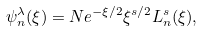<formula> <loc_0><loc_0><loc_500><loc_500>\psi _ { n } ^ { \lambda } ( \xi ) = N e ^ { - \xi / 2 } \xi ^ { s / 2 } L _ { n } ^ { s } ( \xi ) ,</formula> 